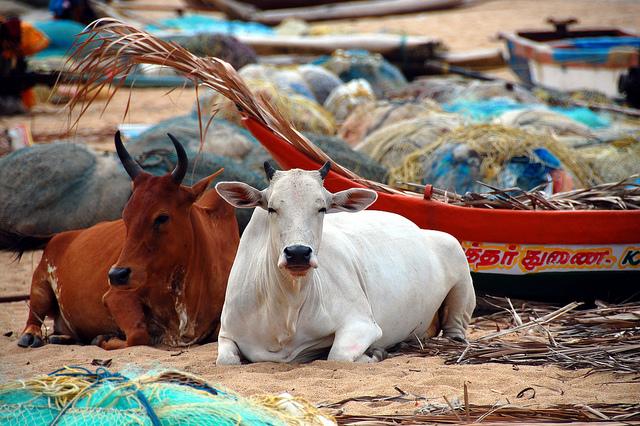Is that English writing on the boat?
Quick response, please. No. Are the animals the same color?
Write a very short answer. No. How many horns are visible?
Give a very brief answer. 4. 